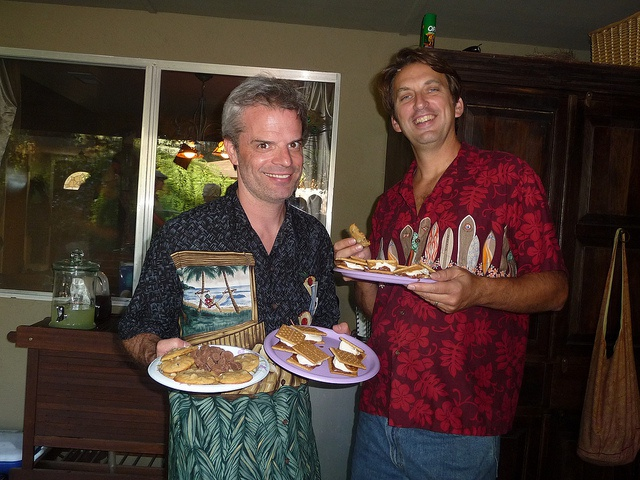Describe the objects in this image and their specific colors. I can see people in black, maroon, and brown tones, people in black, gray, and teal tones, handbag in black, maroon, and olive tones, people in black and darkgreen tones, and bottle in black, gray, darkgreen, and darkgray tones in this image. 